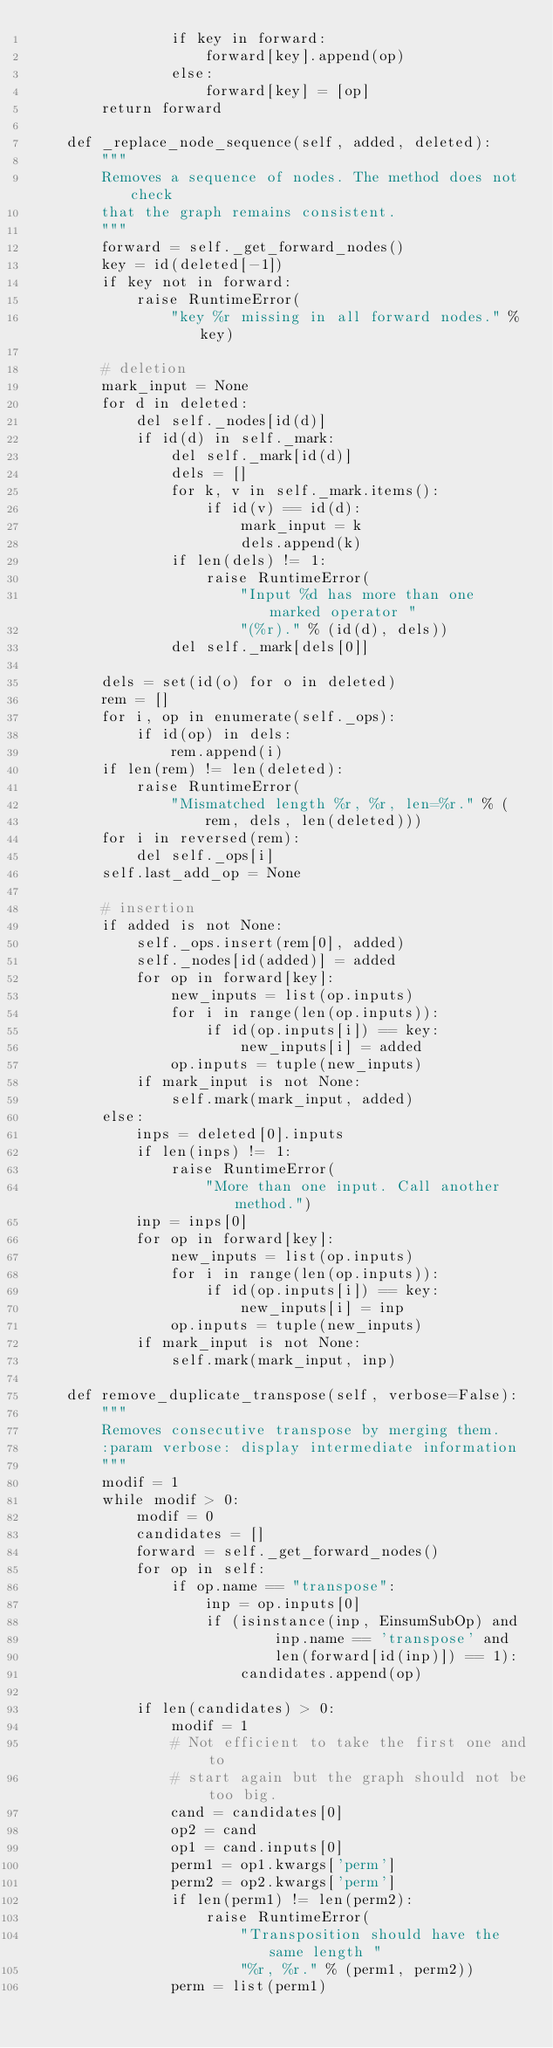Convert code to text. <code><loc_0><loc_0><loc_500><loc_500><_Python_>                if key in forward:
                    forward[key].append(op)
                else:
                    forward[key] = [op]
        return forward

    def _replace_node_sequence(self, added, deleted):
        """
        Removes a sequence of nodes. The method does not check
        that the graph remains consistent.
        """
        forward = self._get_forward_nodes()
        key = id(deleted[-1])
        if key not in forward:
            raise RuntimeError(
                "key %r missing in all forward nodes." % key)

        # deletion
        mark_input = None
        for d in deleted:
            del self._nodes[id(d)]
            if id(d) in self._mark:
                del self._mark[id(d)]
                dels = []
                for k, v in self._mark.items():
                    if id(v) == id(d):
                        mark_input = k
                        dels.append(k)
                if len(dels) != 1:
                    raise RuntimeError(
                        "Input %d has more than one marked operator "
                        "(%r)." % (id(d), dels))
                del self._mark[dels[0]]

        dels = set(id(o) for o in deleted)
        rem = []
        for i, op in enumerate(self._ops):
            if id(op) in dels:
                rem.append(i)
        if len(rem) != len(deleted):
            raise RuntimeError(
                "Mismatched length %r, %r, len=%r." % (
                    rem, dels, len(deleted)))
        for i in reversed(rem):
            del self._ops[i]
        self.last_add_op = None

        # insertion
        if added is not None:
            self._ops.insert(rem[0], added)
            self._nodes[id(added)] = added
            for op in forward[key]:
                new_inputs = list(op.inputs)
                for i in range(len(op.inputs)):
                    if id(op.inputs[i]) == key:
                        new_inputs[i] = added
                op.inputs = tuple(new_inputs)
            if mark_input is not None:
                self.mark(mark_input, added)
        else:
            inps = deleted[0].inputs
            if len(inps) != 1:
                raise RuntimeError(
                    "More than one input. Call another method.")
            inp = inps[0]
            for op in forward[key]:
                new_inputs = list(op.inputs)
                for i in range(len(op.inputs)):
                    if id(op.inputs[i]) == key:
                        new_inputs[i] = inp
                op.inputs = tuple(new_inputs)
            if mark_input is not None:
                self.mark(mark_input, inp)

    def remove_duplicate_transpose(self, verbose=False):
        """
        Removes consecutive transpose by merging them.
        :param verbose: display intermediate information
        """
        modif = 1
        while modif > 0:
            modif = 0
            candidates = []
            forward = self._get_forward_nodes()
            for op in self:
                if op.name == "transpose":
                    inp = op.inputs[0]
                    if (isinstance(inp, EinsumSubOp) and
                            inp.name == 'transpose' and
                            len(forward[id(inp)]) == 1):
                        candidates.append(op)

            if len(candidates) > 0:
                modif = 1
                # Not efficient to take the first one and to
                # start again but the graph should not be too big.
                cand = candidates[0]
                op2 = cand
                op1 = cand.inputs[0]
                perm1 = op1.kwargs['perm']
                perm2 = op2.kwargs['perm']
                if len(perm1) != len(perm2):
                    raise RuntimeError(
                        "Transposition should have the same length "
                        "%r, %r." % (perm1, perm2))
                perm = list(perm1)</code> 